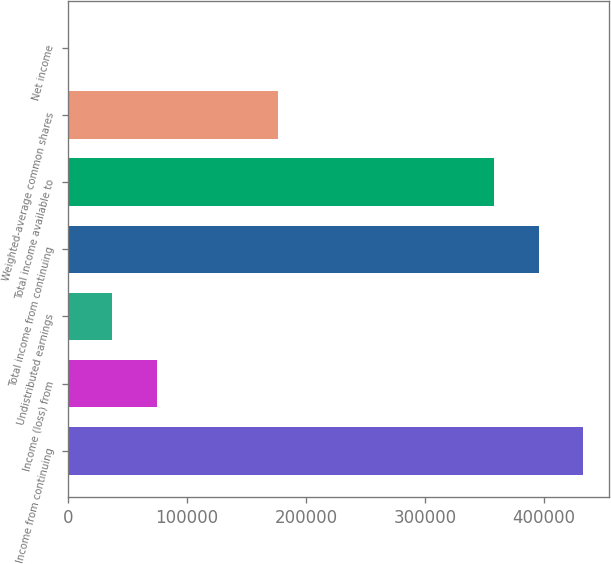<chart> <loc_0><loc_0><loc_500><loc_500><bar_chart><fcel>Income from continuing<fcel>Income (loss) from<fcel>Undistributed earnings<fcel>Total income from continuing<fcel>Total income available to<fcel>Weighted-average common shares<fcel>Net income<nl><fcel>432776<fcel>74851.6<fcel>37426.8<fcel>395351<fcel>357926<fcel>176445<fcel>2.03<nl></chart> 